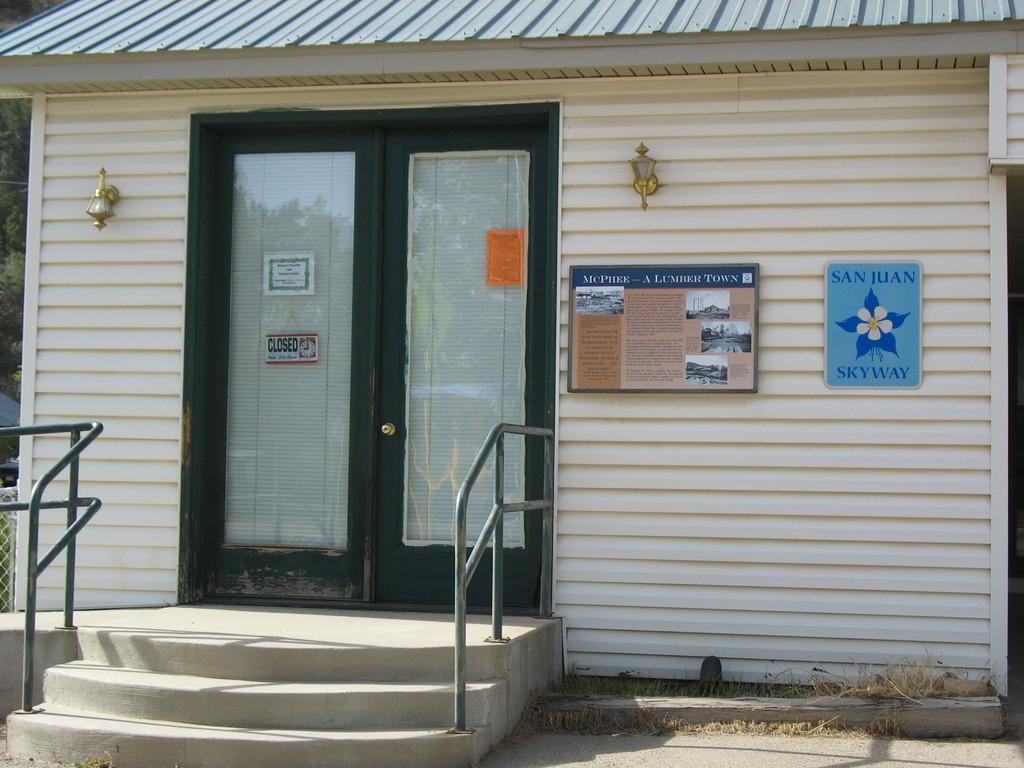Describe this image in one or two sentences. In the center of the image, we can see a shed and there are doors and we can see some posters and boards on the wall and there are stairs and railings and we can see a mesh and some trees. 